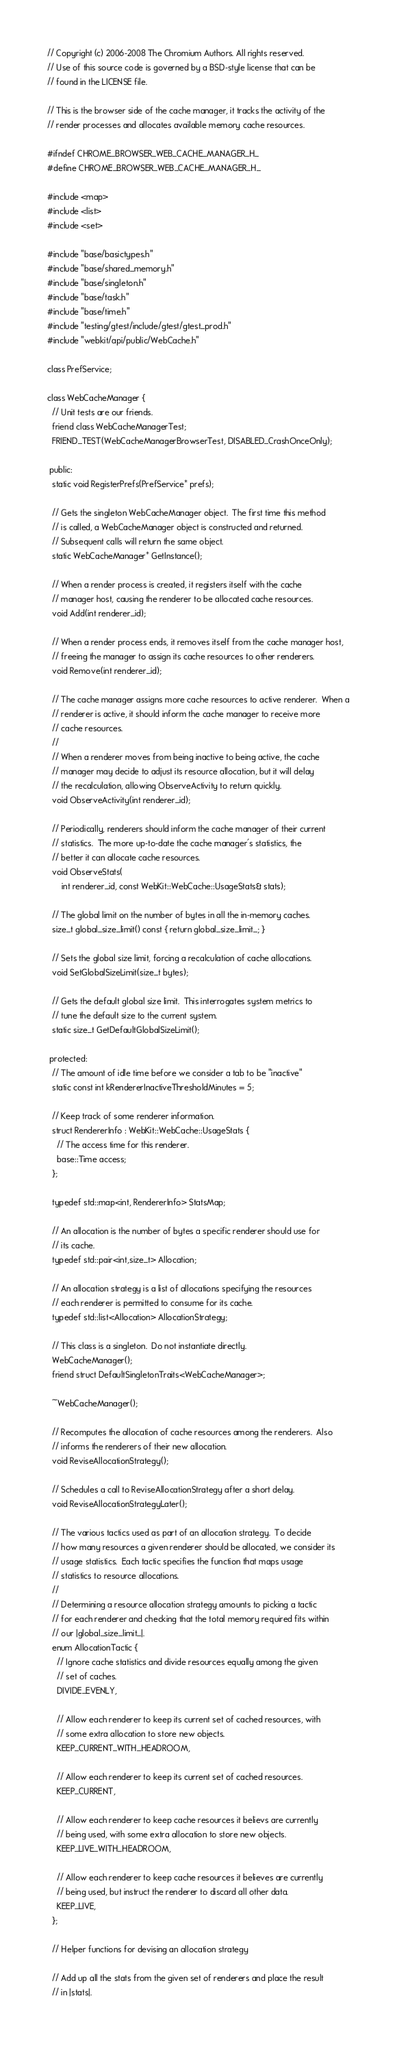Convert code to text. <code><loc_0><loc_0><loc_500><loc_500><_C_>// Copyright (c) 2006-2008 The Chromium Authors. All rights reserved.
// Use of this source code is governed by a BSD-style license that can be
// found in the LICENSE file.

// This is the browser side of the cache manager, it tracks the activity of the
// render processes and allocates available memory cache resources.

#ifndef CHROME_BROWSER_WEB_CACHE_MANAGER_H_
#define CHROME_BROWSER_WEB_CACHE_MANAGER_H_

#include <map>
#include <list>
#include <set>

#include "base/basictypes.h"
#include "base/shared_memory.h"
#include "base/singleton.h"
#include "base/task.h"
#include "base/time.h"
#include "testing/gtest/include/gtest/gtest_prod.h"
#include "webkit/api/public/WebCache.h"

class PrefService;

class WebCacheManager {
  // Unit tests are our friends.
  friend class WebCacheManagerTest;
  FRIEND_TEST(WebCacheManagerBrowserTest, DISABLED_CrashOnceOnly);

 public:
  static void RegisterPrefs(PrefService* prefs);

  // Gets the singleton WebCacheManager object.  The first time this method
  // is called, a WebCacheManager object is constructed and returned.
  // Subsequent calls will return the same object.
  static WebCacheManager* GetInstance();

  // When a render process is created, it registers itself with the cache
  // manager host, causing the renderer to be allocated cache resources.
  void Add(int renderer_id);

  // When a render process ends, it removes itself from the cache manager host,
  // freeing the manager to assign its cache resources to other renderers.
  void Remove(int renderer_id);

  // The cache manager assigns more cache resources to active renderer.  When a
  // renderer is active, it should inform the cache manager to receive more
  // cache resources.
  //
  // When a renderer moves from being inactive to being active, the cache
  // manager may decide to adjust its resource allocation, but it will delay
  // the recalculation, allowing ObserveActivity to return quickly.
  void ObserveActivity(int renderer_id);

  // Periodically, renderers should inform the cache manager of their current
  // statistics.  The more up-to-date the cache manager's statistics, the
  // better it can allocate cache resources.
  void ObserveStats(
      int renderer_id, const WebKit::WebCache::UsageStats& stats);

  // The global limit on the number of bytes in all the in-memory caches.
  size_t global_size_limit() const { return global_size_limit_; }

  // Sets the global size limit, forcing a recalculation of cache allocations.
  void SetGlobalSizeLimit(size_t bytes);

  // Gets the default global size limit.  This interrogates system metrics to
  // tune the default size to the current system.
  static size_t GetDefaultGlobalSizeLimit();

 protected:
  // The amount of idle time before we consider a tab to be "inactive"
  static const int kRendererInactiveThresholdMinutes = 5;

  // Keep track of some renderer information.
  struct RendererInfo : WebKit::WebCache::UsageStats {
    // The access time for this renderer.
    base::Time access;
  };

  typedef std::map<int, RendererInfo> StatsMap;

  // An allocation is the number of bytes a specific renderer should use for
  // its cache.
  typedef std::pair<int,size_t> Allocation;

  // An allocation strategy is a list of allocations specifying the resources
  // each renderer is permitted to consume for its cache.
  typedef std::list<Allocation> AllocationStrategy;

  // This class is a singleton.  Do not instantiate directly.
  WebCacheManager();
  friend struct DefaultSingletonTraits<WebCacheManager>;

  ~WebCacheManager();

  // Recomputes the allocation of cache resources among the renderers.  Also
  // informs the renderers of their new allocation.
  void ReviseAllocationStrategy();

  // Schedules a call to ReviseAllocationStrategy after a short delay.
  void ReviseAllocationStrategyLater();

  // The various tactics used as part of an allocation strategy.  To decide
  // how many resources a given renderer should be allocated, we consider its
  // usage statistics.  Each tactic specifies the function that maps usage
  // statistics to resource allocations.
  //
  // Determining a resource allocation strategy amounts to picking a tactic
  // for each renderer and checking that the total memory required fits within
  // our |global_size_limit_|.
  enum AllocationTactic {
    // Ignore cache statistics and divide resources equally among the given
    // set of caches.
    DIVIDE_EVENLY,

    // Allow each renderer to keep its current set of cached resources, with
    // some extra allocation to store new objects.
    KEEP_CURRENT_WITH_HEADROOM,

    // Allow each renderer to keep its current set of cached resources.
    KEEP_CURRENT,

    // Allow each renderer to keep cache resources it believs are currently
    // being used, with some extra allocation to store new objects.
    KEEP_LIVE_WITH_HEADROOM,

    // Allow each renderer to keep cache resources it believes are currently
    // being used, but instruct the renderer to discard all other data.
    KEEP_LIVE,
  };

  // Helper functions for devising an allocation strategy

  // Add up all the stats from the given set of renderers and place the result
  // in |stats|.</code> 